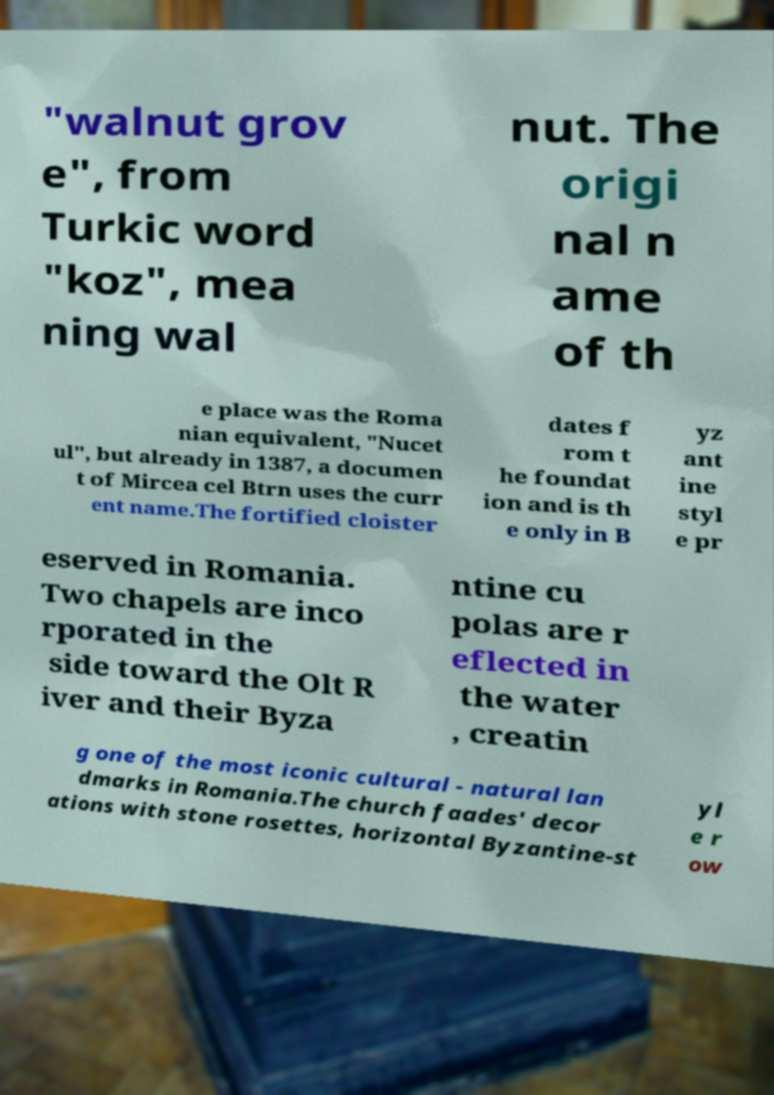Could you assist in decoding the text presented in this image and type it out clearly? "walnut grov e", from Turkic word "koz", mea ning wal nut. The origi nal n ame of th e place was the Roma nian equivalent, "Nucet ul", but already in 1387, a documen t of Mircea cel Btrn uses the curr ent name.The fortified cloister dates f rom t he foundat ion and is th e only in B yz ant ine styl e pr eserved in Romania. Two chapels are inco rporated in the side toward the Olt R iver and their Byza ntine cu polas are r eflected in the water , creatin g one of the most iconic cultural - natural lan dmarks in Romania.The church faades' decor ations with stone rosettes, horizontal Byzantine-st yl e r ow 